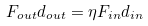Convert formula to latex. <formula><loc_0><loc_0><loc_500><loc_500>F _ { o u t } d _ { o u t } = \eta F _ { i n } d _ { i n }</formula> 